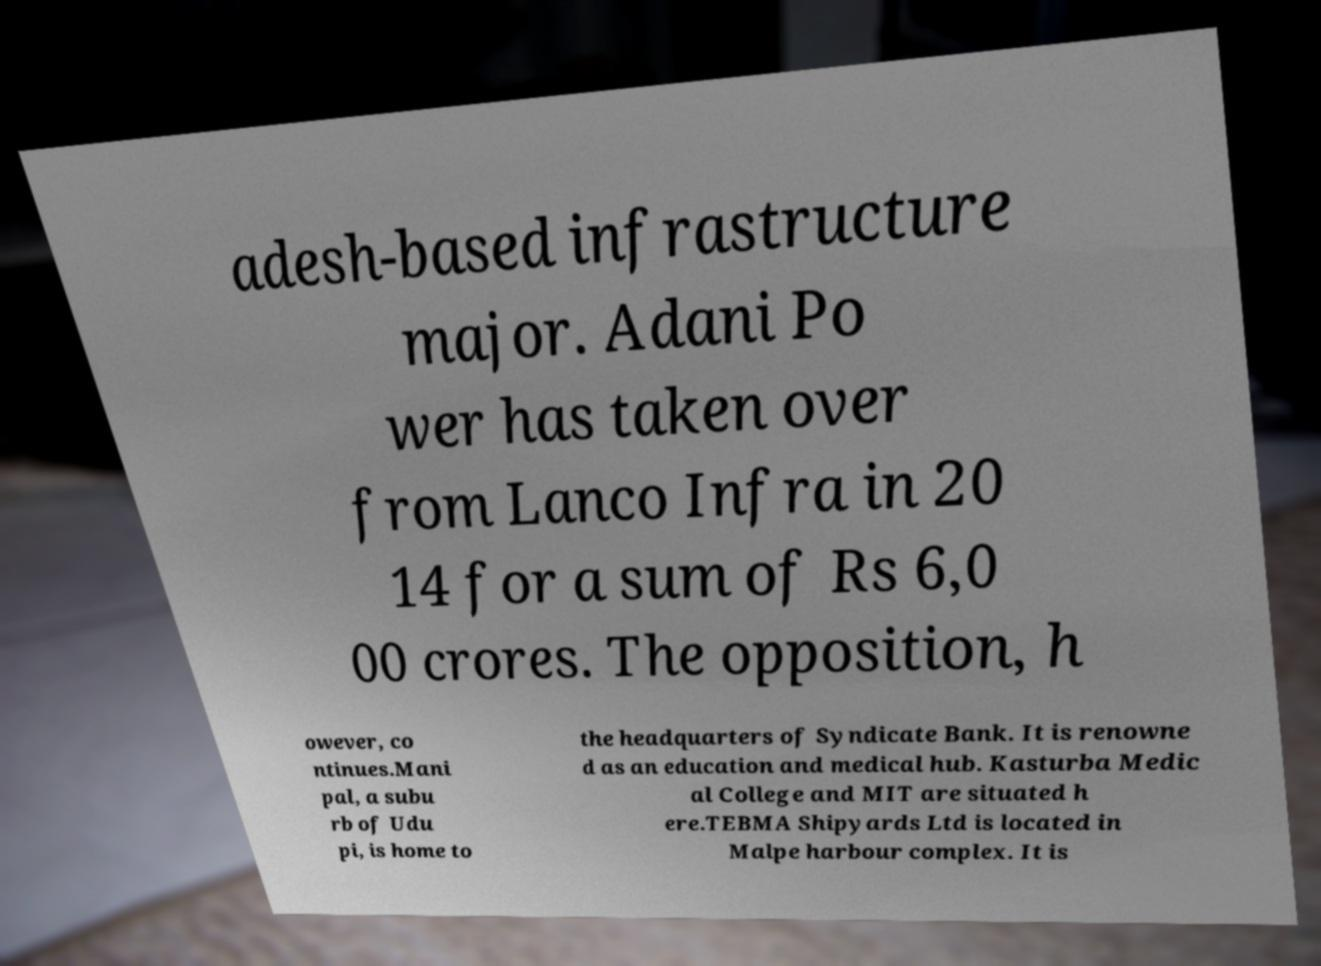Could you extract and type out the text from this image? adesh-based infrastructure major. Adani Po wer has taken over from Lanco Infra in 20 14 for a sum of Rs 6,0 00 crores. The opposition, h owever, co ntinues.Mani pal, a subu rb of Udu pi, is home to the headquarters of Syndicate Bank. It is renowne d as an education and medical hub. Kasturba Medic al College and MIT are situated h ere.TEBMA Shipyards Ltd is located in Malpe harbour complex. It is 